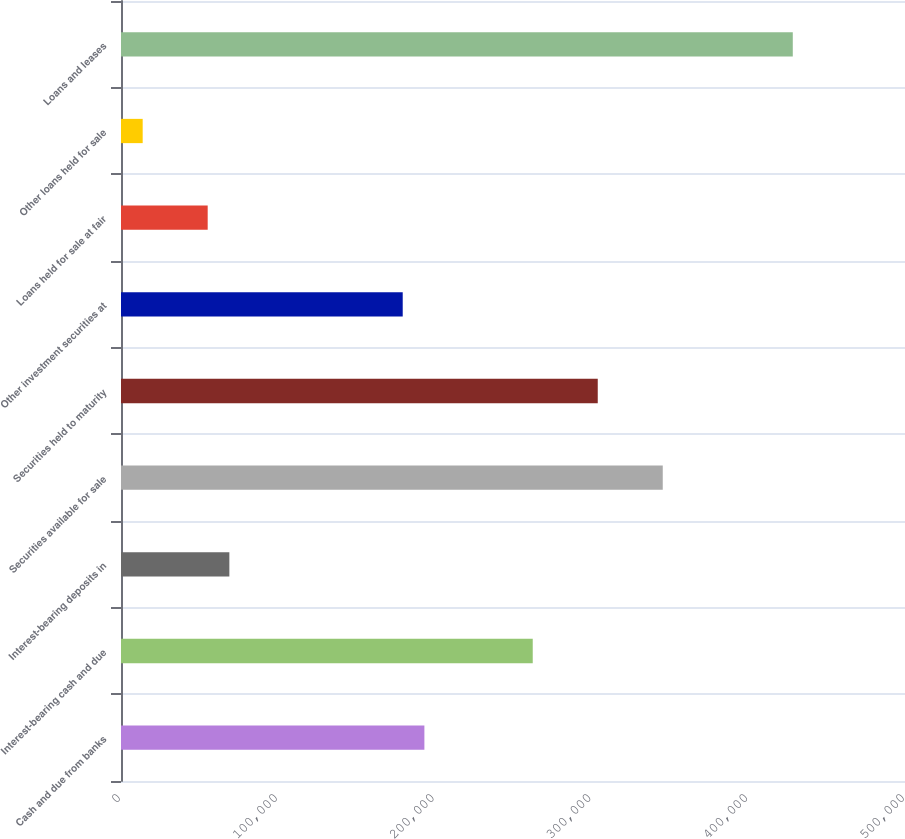Convert chart. <chart><loc_0><loc_0><loc_500><loc_500><bar_chart><fcel>Cash and due from banks<fcel>Interest-bearing cash and due<fcel>Interest-bearing deposits in<fcel>Securities available for sale<fcel>Securities held to maturity<fcel>Other investment securities at<fcel>Loans held for sale at fair<fcel>Other loans held for sale<fcel>Loans and leases<nl><fcel>193489<fcel>262590<fcel>69107<fcel>345511<fcel>304050<fcel>179669<fcel>55286.8<fcel>13826.2<fcel>428432<nl></chart> 